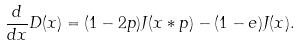Convert formula to latex. <formula><loc_0><loc_0><loc_500><loc_500>\frac { d } { d x } D ( x ) = ( 1 - 2 p ) J ( x * p ) - ( 1 - e ) J ( x ) .</formula> 